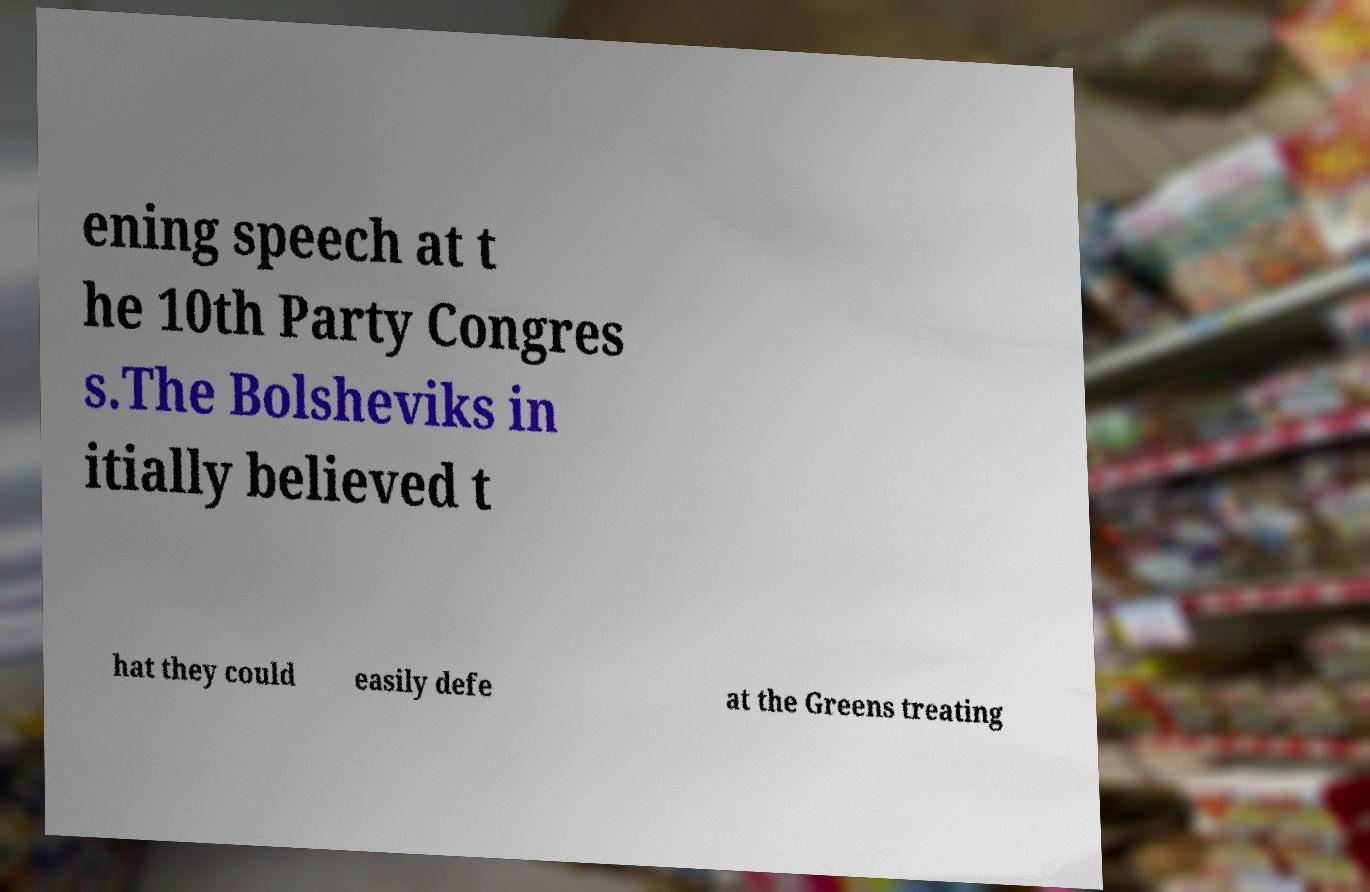What messages or text are displayed in this image? I need them in a readable, typed format. ening speech at t he 10th Party Congres s.The Bolsheviks in itially believed t hat they could easily defe at the Greens treating 